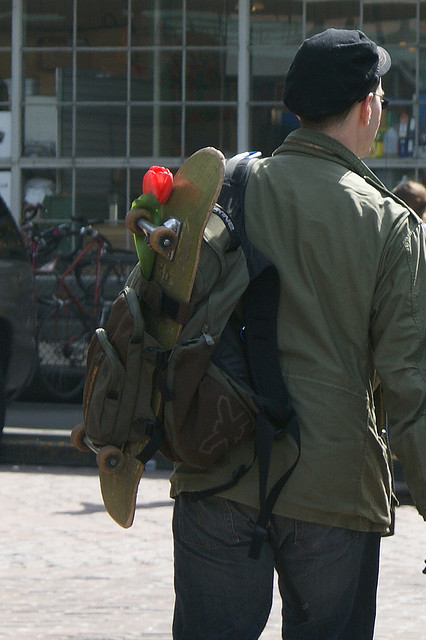Please transcribe the text in this image. t 